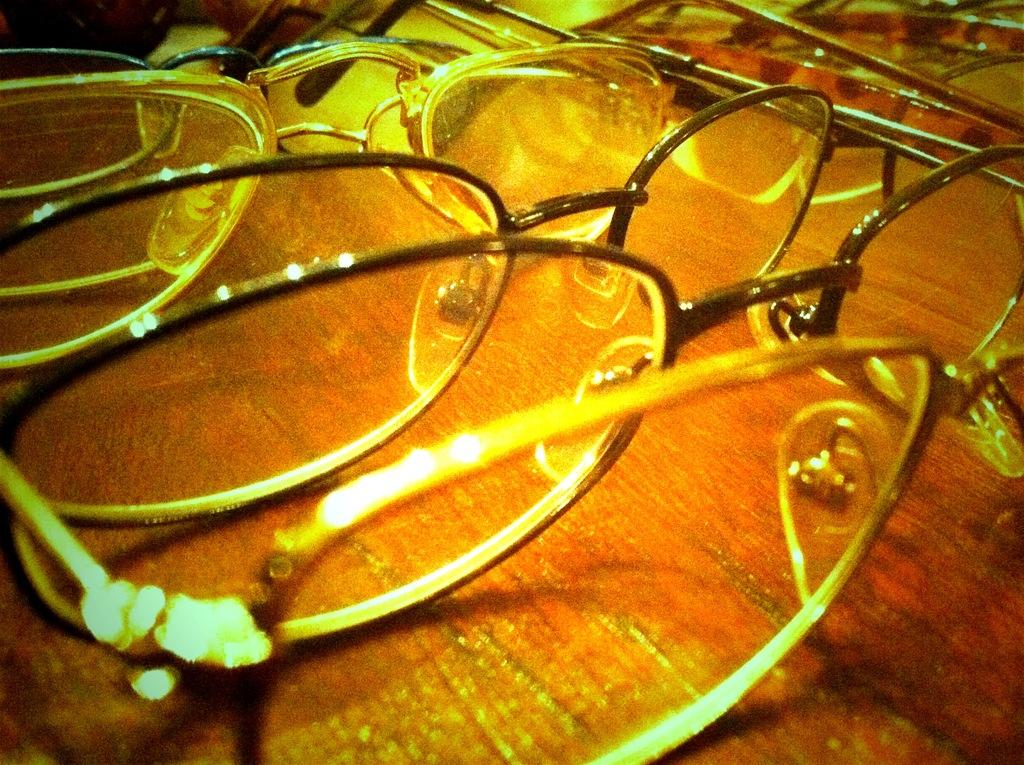What type of accessory is present in the image? There are spectacles in the image. Can you describe the appearance of the spectacles? The provided facts do not include a description of the spectacles' appearance. What might the spectacles be used for? Spectacles are typically used for vision correction or protection. What type of request is being made by the spectacles in the image? There is no indication in the image that the spectacles are making any requests, as they are inanimate objects. 